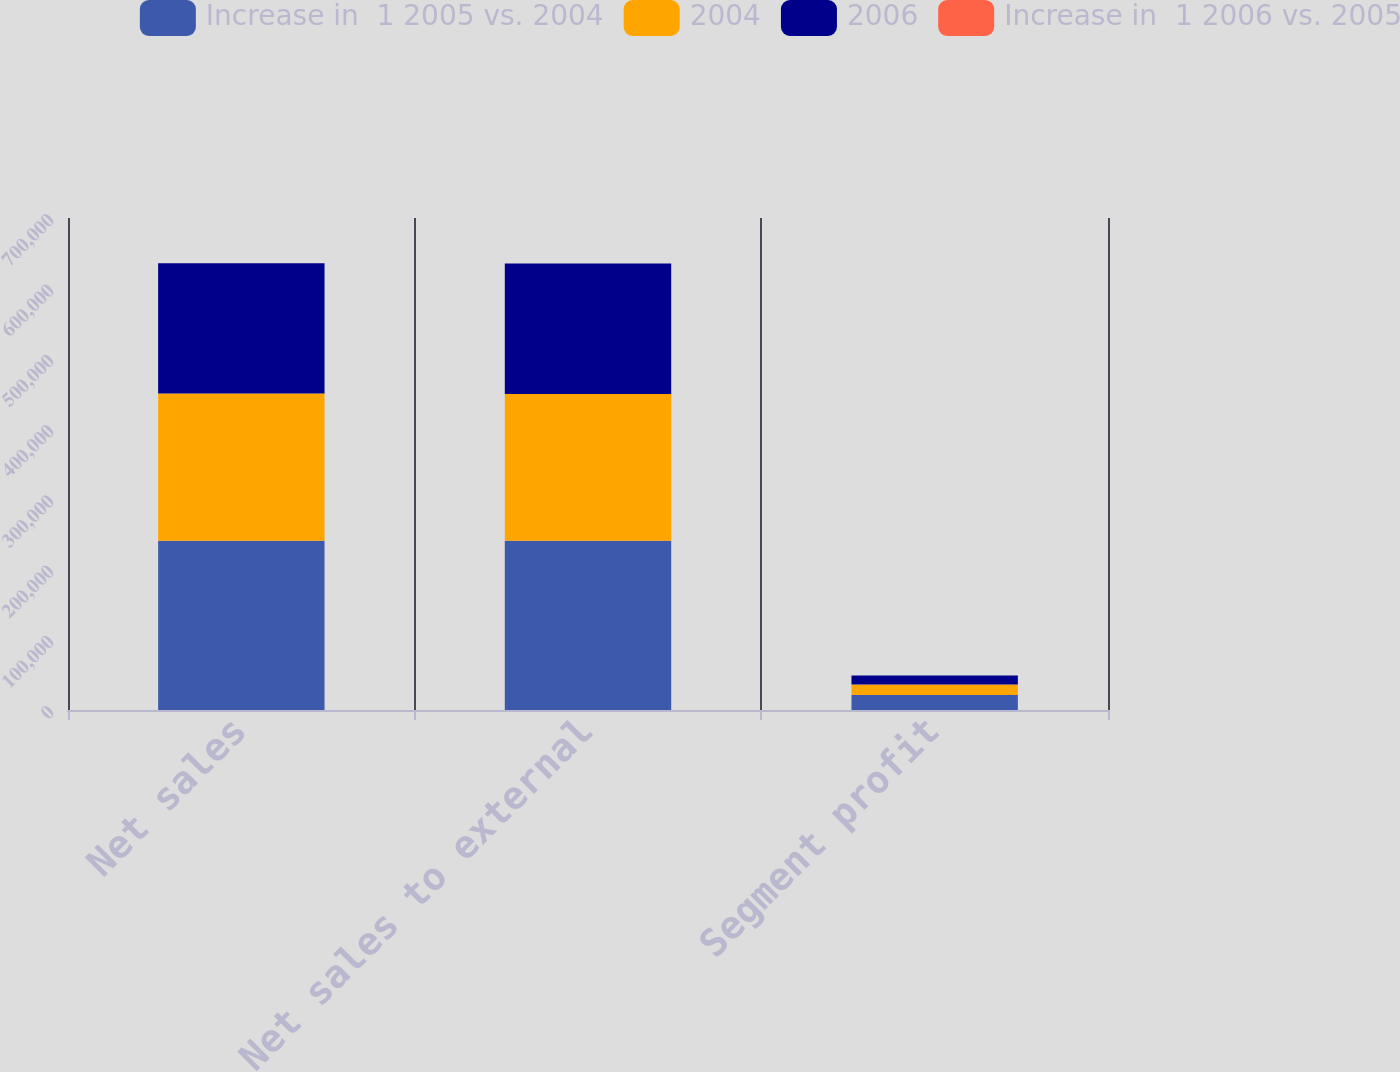Convert chart. <chart><loc_0><loc_0><loc_500><loc_500><stacked_bar_chart><ecel><fcel>Net sales<fcel>Net sales to external<fcel>Segment profit<nl><fcel>Increase in  1 2005 vs. 2004<fcel>240869<fcel>240869<fcel>21412<nl><fcel>2004<fcel>209454<fcel>208895<fcel>14745<nl><fcel>2006<fcel>185325<fcel>185325<fcel>12882<nl><fcel>Increase in  1 2006 vs. 2005<fcel>15<fcel>15<fcel>45<nl></chart> 